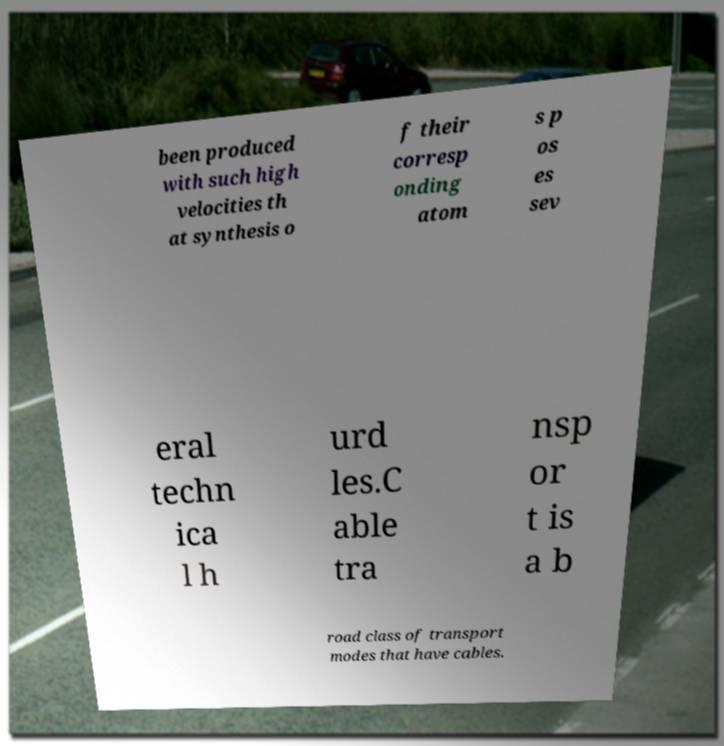Please identify and transcribe the text found in this image. been produced with such high velocities th at synthesis o f their corresp onding atom s p os es sev eral techn ica l h urd les.C able tra nsp or t is a b road class of transport modes that have cables. 